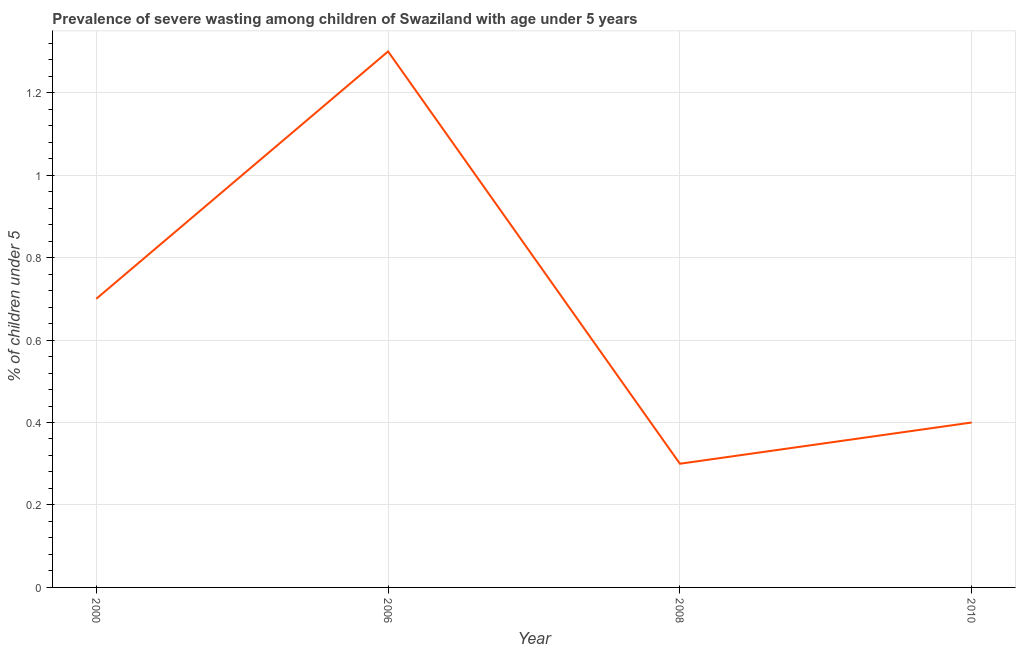What is the prevalence of severe wasting in 2010?
Make the answer very short. 0.4. Across all years, what is the maximum prevalence of severe wasting?
Make the answer very short. 1.3. Across all years, what is the minimum prevalence of severe wasting?
Make the answer very short. 0.3. In which year was the prevalence of severe wasting maximum?
Provide a succinct answer. 2006. In which year was the prevalence of severe wasting minimum?
Ensure brevity in your answer.  2008. What is the sum of the prevalence of severe wasting?
Your answer should be very brief. 2.7. What is the difference between the prevalence of severe wasting in 2006 and 2010?
Offer a very short reply. 0.9. What is the average prevalence of severe wasting per year?
Give a very brief answer. 0.67. What is the median prevalence of severe wasting?
Provide a short and direct response. 0.55. In how many years, is the prevalence of severe wasting greater than 0.12 %?
Your answer should be very brief. 4. Do a majority of the years between 2006 and 2008 (inclusive) have prevalence of severe wasting greater than 0.7600000000000001 %?
Provide a short and direct response. No. What is the ratio of the prevalence of severe wasting in 2006 to that in 2010?
Your response must be concise. 3.25. Is the difference between the prevalence of severe wasting in 2008 and 2010 greater than the difference between any two years?
Make the answer very short. No. What is the difference between the highest and the second highest prevalence of severe wasting?
Provide a short and direct response. 0.6. Is the sum of the prevalence of severe wasting in 2006 and 2010 greater than the maximum prevalence of severe wasting across all years?
Keep it short and to the point. Yes. What is the difference between the highest and the lowest prevalence of severe wasting?
Offer a terse response. 1. In how many years, is the prevalence of severe wasting greater than the average prevalence of severe wasting taken over all years?
Your response must be concise. 2. Does the prevalence of severe wasting monotonically increase over the years?
Your answer should be very brief. No. How many lines are there?
Make the answer very short. 1. What is the difference between two consecutive major ticks on the Y-axis?
Offer a very short reply. 0.2. Does the graph contain grids?
Make the answer very short. Yes. What is the title of the graph?
Your answer should be compact. Prevalence of severe wasting among children of Swaziland with age under 5 years. What is the label or title of the X-axis?
Give a very brief answer. Year. What is the label or title of the Y-axis?
Give a very brief answer.  % of children under 5. What is the  % of children under 5 in 2000?
Ensure brevity in your answer.  0.7. What is the  % of children under 5 of 2006?
Keep it short and to the point. 1.3. What is the  % of children under 5 of 2008?
Offer a very short reply. 0.3. What is the  % of children under 5 of 2010?
Your answer should be compact. 0.4. What is the difference between the  % of children under 5 in 2000 and 2008?
Your answer should be very brief. 0.4. What is the difference between the  % of children under 5 in 2000 and 2010?
Your answer should be very brief. 0.3. What is the difference between the  % of children under 5 in 2006 and 2010?
Provide a succinct answer. 0.9. What is the difference between the  % of children under 5 in 2008 and 2010?
Your answer should be compact. -0.1. What is the ratio of the  % of children under 5 in 2000 to that in 2006?
Offer a terse response. 0.54. What is the ratio of the  % of children under 5 in 2000 to that in 2008?
Your answer should be very brief. 2.33. What is the ratio of the  % of children under 5 in 2006 to that in 2008?
Give a very brief answer. 4.33. What is the ratio of the  % of children under 5 in 2008 to that in 2010?
Provide a short and direct response. 0.75. 